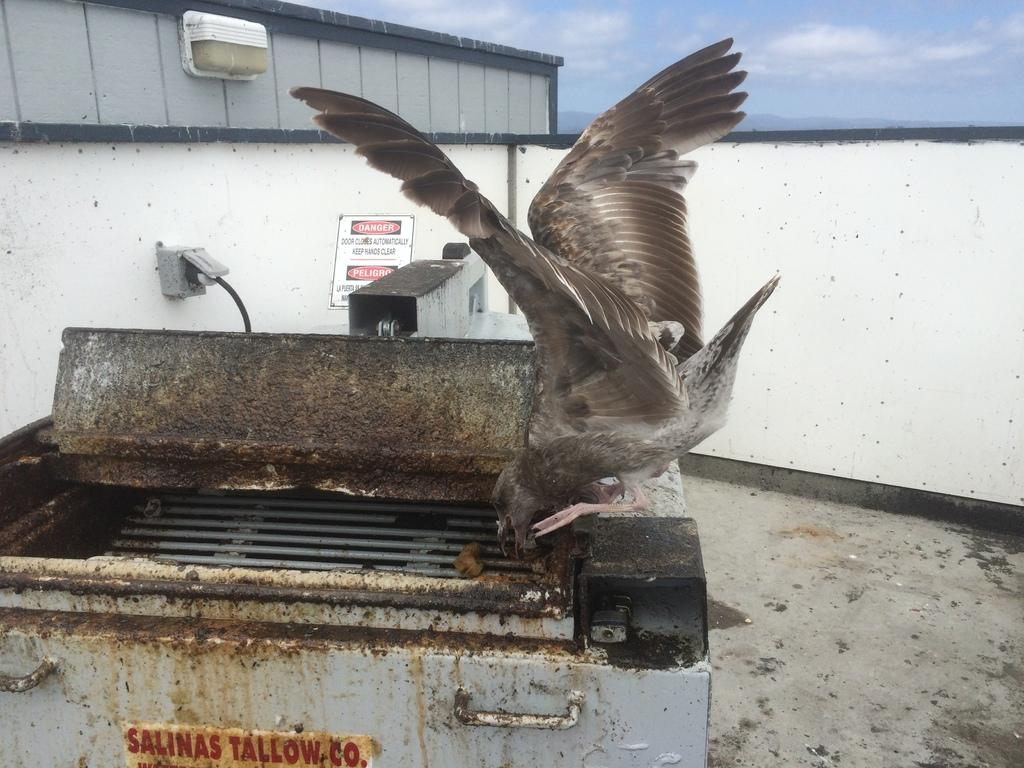What can be seen in the image that is used for cooking? There is a grill in the image that is used for cooking. What type of animal is on the grill? A bird is on the grill. What is written on the wall in the image? There is a board with text on the wall. How would you describe the sky in the image? The sky is blue and cloudy. What is written on the grill? There is text on the grill. Can you tell me what the argument was about in the image? There is no argument present in the image. What is the bird's interest in the image? The image does not provide information about the bird's interests. 